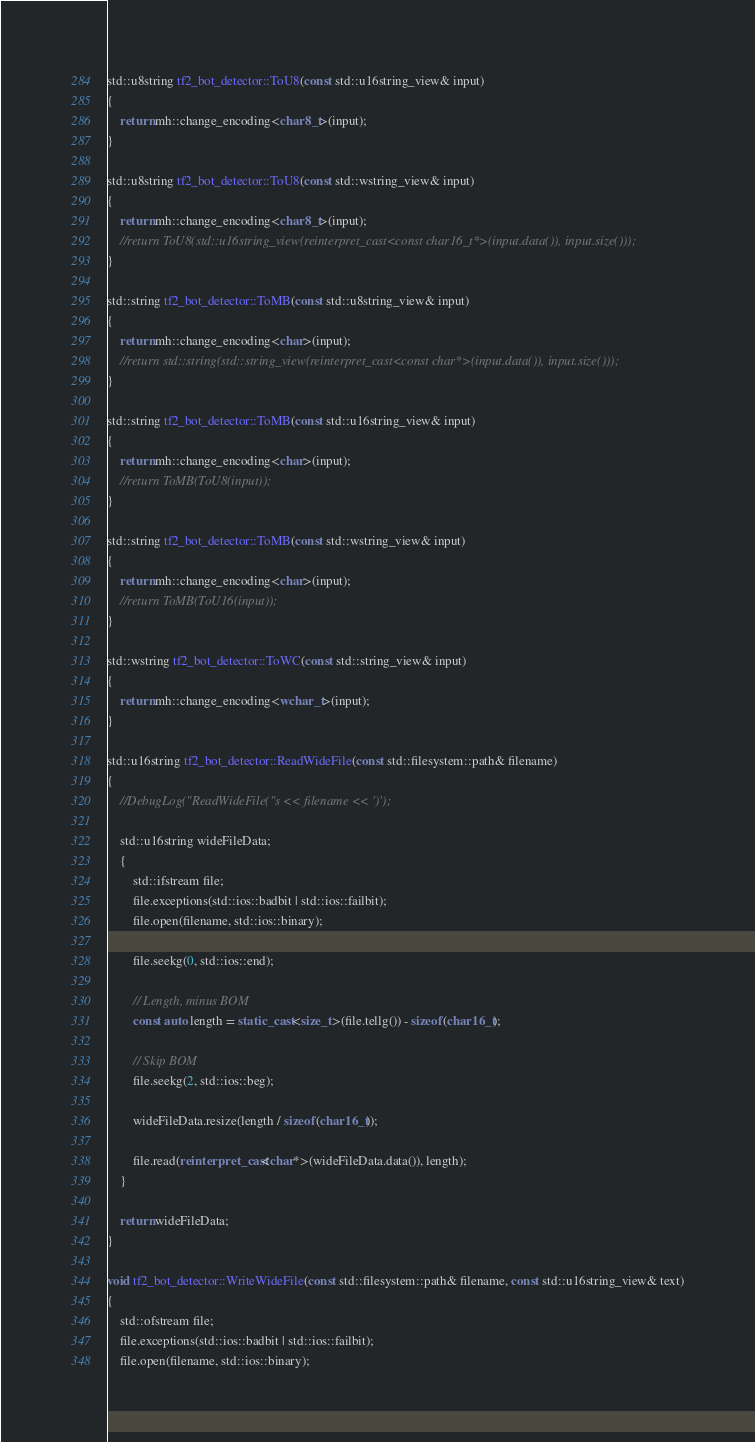<code> <loc_0><loc_0><loc_500><loc_500><_C++_>
std::u8string tf2_bot_detector::ToU8(const std::u16string_view& input)
{
	return mh::change_encoding<char8_t>(input);
}

std::u8string tf2_bot_detector::ToU8(const std::wstring_view& input)
{
	return mh::change_encoding<char8_t>(input);
	//return ToU8(std::u16string_view(reinterpret_cast<const char16_t*>(input.data()), input.size()));
}

std::string tf2_bot_detector::ToMB(const std::u8string_view& input)
{
	return mh::change_encoding<char>(input);
	//return std::string(std::string_view(reinterpret_cast<const char*>(input.data()), input.size()));
}

std::string tf2_bot_detector::ToMB(const std::u16string_view& input)
{
	return mh::change_encoding<char>(input);
	//return ToMB(ToU8(input));
}

std::string tf2_bot_detector::ToMB(const std::wstring_view& input)
{
	return mh::change_encoding<char>(input);
	//return ToMB(ToU16(input));
}

std::wstring tf2_bot_detector::ToWC(const std::string_view& input)
{
	return mh::change_encoding<wchar_t>(input);
}

std::u16string tf2_bot_detector::ReadWideFile(const std::filesystem::path& filename)
{
	//DebugLog("ReadWideFile("s << filename << ')');

	std::u16string wideFileData;
	{
		std::ifstream file;
		file.exceptions(std::ios::badbit | std::ios::failbit);
		file.open(filename, std::ios::binary);

		file.seekg(0, std::ios::end);

		// Length, minus BOM
		const auto length = static_cast<size_t>(file.tellg()) - sizeof(char16_t);

		// Skip BOM
		file.seekg(2, std::ios::beg);

		wideFileData.resize(length / sizeof(char16_t));

		file.read(reinterpret_cast<char*>(wideFileData.data()), length);
	}

	return wideFileData;
}

void tf2_bot_detector::WriteWideFile(const std::filesystem::path& filename, const std::u16string_view& text)
{
	std::ofstream file;
	file.exceptions(std::ios::badbit | std::ios::failbit);
	file.open(filename, std::ios::binary);</code> 